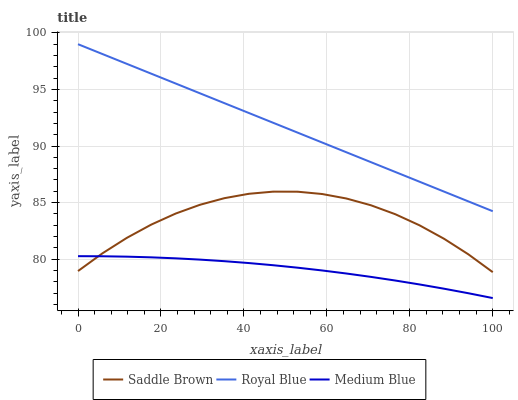Does Saddle Brown have the minimum area under the curve?
Answer yes or no. No. Does Saddle Brown have the maximum area under the curve?
Answer yes or no. No. Is Medium Blue the smoothest?
Answer yes or no. No. Is Medium Blue the roughest?
Answer yes or no. No. Does Saddle Brown have the lowest value?
Answer yes or no. No. Does Saddle Brown have the highest value?
Answer yes or no. No. Is Medium Blue less than Royal Blue?
Answer yes or no. Yes. Is Royal Blue greater than Saddle Brown?
Answer yes or no. Yes. Does Medium Blue intersect Royal Blue?
Answer yes or no. No. 